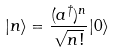Convert formula to latex. <formula><loc_0><loc_0><loc_500><loc_500>| n \rangle = \frac { ( a ^ { \dag } ) ^ { n } } { \sqrt { n ! } } | 0 \rangle</formula> 